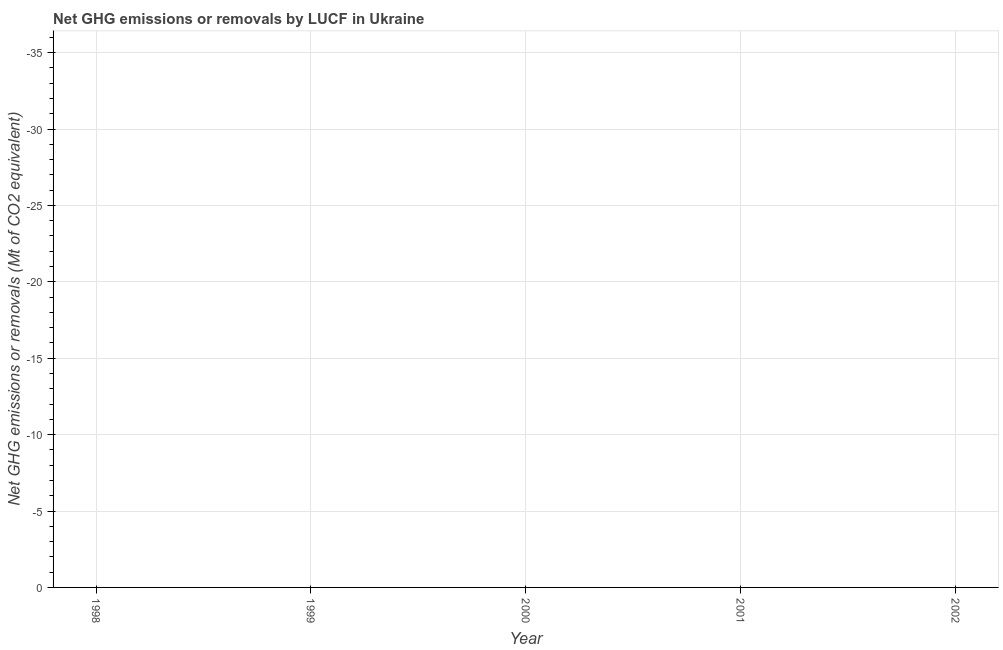Across all years, what is the minimum ghg net emissions or removals?
Your answer should be compact. 0. In how many years, is the ghg net emissions or removals greater than -32 Mt?
Make the answer very short. 0. In how many years, is the ghg net emissions or removals greater than the average ghg net emissions or removals taken over all years?
Your answer should be compact. 0. How many lines are there?
Keep it short and to the point. 0. How many years are there in the graph?
Offer a terse response. 5. What is the difference between two consecutive major ticks on the Y-axis?
Your response must be concise. 5. Does the graph contain any zero values?
Offer a very short reply. Yes. Does the graph contain grids?
Give a very brief answer. Yes. What is the title of the graph?
Make the answer very short. Net GHG emissions or removals by LUCF in Ukraine. What is the label or title of the X-axis?
Offer a very short reply. Year. What is the label or title of the Y-axis?
Your answer should be compact. Net GHG emissions or removals (Mt of CO2 equivalent). What is the Net GHG emissions or removals (Mt of CO2 equivalent) in 1998?
Your response must be concise. 0. What is the Net GHG emissions or removals (Mt of CO2 equivalent) in 2000?
Your answer should be compact. 0. What is the Net GHG emissions or removals (Mt of CO2 equivalent) of 2001?
Make the answer very short. 0. What is the Net GHG emissions or removals (Mt of CO2 equivalent) in 2002?
Ensure brevity in your answer.  0. 